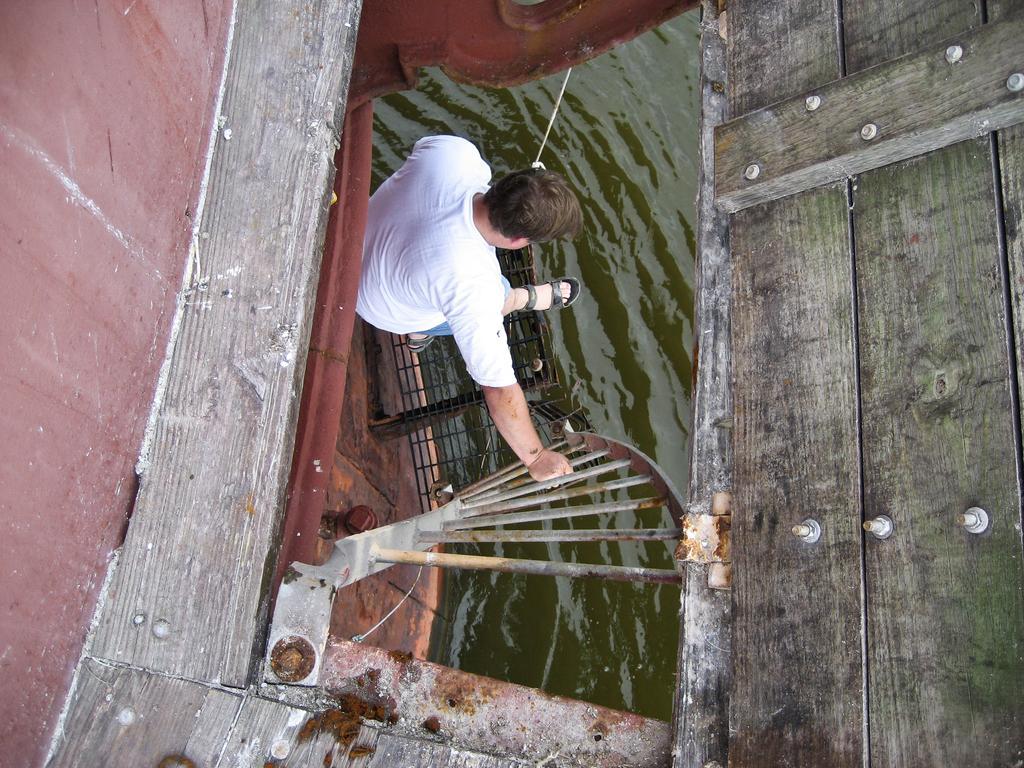Could you give a brief overview of what you see in this image? In the middle I can see a person on the steps, fence and a wall. In the background I can see water and a wooden fence. This image is taken may be during a day. 